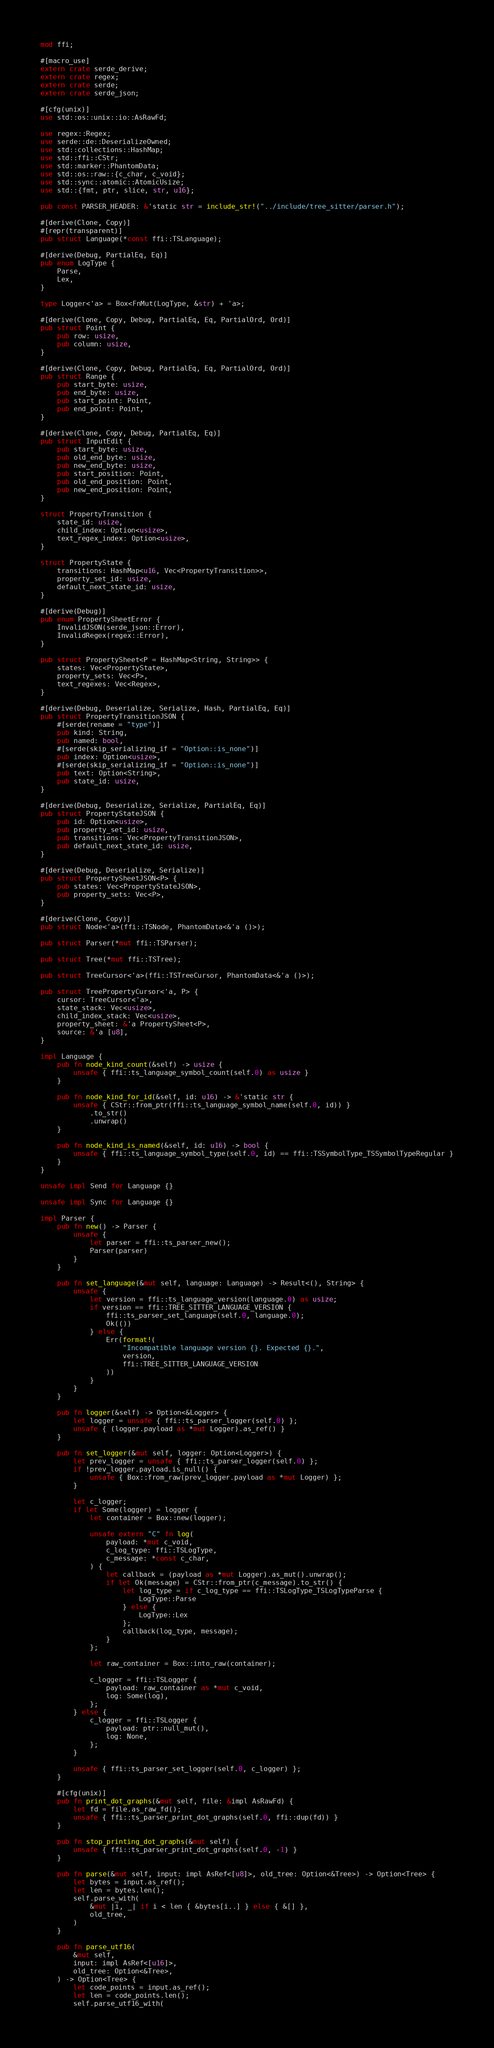<code> <loc_0><loc_0><loc_500><loc_500><_Rust_>mod ffi;

#[macro_use]
extern crate serde_derive;
extern crate regex;
extern crate serde;
extern crate serde_json;

#[cfg(unix)]
use std::os::unix::io::AsRawFd;

use regex::Regex;
use serde::de::DeserializeOwned;
use std::collections::HashMap;
use std::ffi::CStr;
use std::marker::PhantomData;
use std::os::raw::{c_char, c_void};
use std::sync::atomic::AtomicUsize;
use std::{fmt, ptr, slice, str, u16};

pub const PARSER_HEADER: &'static str = include_str!("../include/tree_sitter/parser.h");

#[derive(Clone, Copy)]
#[repr(transparent)]
pub struct Language(*const ffi::TSLanguage);

#[derive(Debug, PartialEq, Eq)]
pub enum LogType {
    Parse,
    Lex,
}

type Logger<'a> = Box<FnMut(LogType, &str) + 'a>;

#[derive(Clone, Copy, Debug, PartialEq, Eq, PartialOrd, Ord)]
pub struct Point {
    pub row: usize,
    pub column: usize,
}

#[derive(Clone, Copy, Debug, PartialEq, Eq, PartialOrd, Ord)]
pub struct Range {
    pub start_byte: usize,
    pub end_byte: usize,
    pub start_point: Point,
    pub end_point: Point,
}

#[derive(Clone, Copy, Debug, PartialEq, Eq)]
pub struct InputEdit {
    pub start_byte: usize,
    pub old_end_byte: usize,
    pub new_end_byte: usize,
    pub start_position: Point,
    pub old_end_position: Point,
    pub new_end_position: Point,
}

struct PropertyTransition {
    state_id: usize,
    child_index: Option<usize>,
    text_regex_index: Option<usize>,
}

struct PropertyState {
    transitions: HashMap<u16, Vec<PropertyTransition>>,
    property_set_id: usize,
    default_next_state_id: usize,
}

#[derive(Debug)]
pub enum PropertySheetError {
    InvalidJSON(serde_json::Error),
    InvalidRegex(regex::Error),
}

pub struct PropertySheet<P = HashMap<String, String>> {
    states: Vec<PropertyState>,
    property_sets: Vec<P>,
    text_regexes: Vec<Regex>,
}

#[derive(Debug, Deserialize, Serialize, Hash, PartialEq, Eq)]
pub struct PropertyTransitionJSON {
    #[serde(rename = "type")]
    pub kind: String,
    pub named: bool,
    #[serde(skip_serializing_if = "Option::is_none")]
    pub index: Option<usize>,
    #[serde(skip_serializing_if = "Option::is_none")]
    pub text: Option<String>,
    pub state_id: usize,
}

#[derive(Debug, Deserialize, Serialize, PartialEq, Eq)]
pub struct PropertyStateJSON {
    pub id: Option<usize>,
    pub property_set_id: usize,
    pub transitions: Vec<PropertyTransitionJSON>,
    pub default_next_state_id: usize,
}

#[derive(Debug, Deserialize, Serialize)]
pub struct PropertySheetJSON<P> {
    pub states: Vec<PropertyStateJSON>,
    pub property_sets: Vec<P>,
}

#[derive(Clone, Copy)]
pub struct Node<'a>(ffi::TSNode, PhantomData<&'a ()>);

pub struct Parser(*mut ffi::TSParser);

pub struct Tree(*mut ffi::TSTree);

pub struct TreeCursor<'a>(ffi::TSTreeCursor, PhantomData<&'a ()>);

pub struct TreePropertyCursor<'a, P> {
    cursor: TreeCursor<'a>,
    state_stack: Vec<usize>,
    child_index_stack: Vec<usize>,
    property_sheet: &'a PropertySheet<P>,
    source: &'a [u8],
}

impl Language {
    pub fn node_kind_count(&self) -> usize {
        unsafe { ffi::ts_language_symbol_count(self.0) as usize }
    }

    pub fn node_kind_for_id(&self, id: u16) -> &'static str {
        unsafe { CStr::from_ptr(ffi::ts_language_symbol_name(self.0, id)) }
            .to_str()
            .unwrap()
    }

    pub fn node_kind_is_named(&self, id: u16) -> bool {
        unsafe { ffi::ts_language_symbol_type(self.0, id) == ffi::TSSymbolType_TSSymbolTypeRegular }
    }
}

unsafe impl Send for Language {}

unsafe impl Sync for Language {}

impl Parser {
    pub fn new() -> Parser {
        unsafe {
            let parser = ffi::ts_parser_new();
            Parser(parser)
        }
    }

    pub fn set_language(&mut self, language: Language) -> Result<(), String> {
        unsafe {
            let version = ffi::ts_language_version(language.0) as usize;
            if version == ffi::TREE_SITTER_LANGUAGE_VERSION {
                ffi::ts_parser_set_language(self.0, language.0);
                Ok(())
            } else {
                Err(format!(
                    "Incompatible language version {}. Expected {}.",
                    version,
                    ffi::TREE_SITTER_LANGUAGE_VERSION
                ))
            }
        }
    }

    pub fn logger(&self) -> Option<&Logger> {
        let logger = unsafe { ffi::ts_parser_logger(self.0) };
        unsafe { (logger.payload as *mut Logger).as_ref() }
    }

    pub fn set_logger(&mut self, logger: Option<Logger>) {
        let prev_logger = unsafe { ffi::ts_parser_logger(self.0) };
        if !prev_logger.payload.is_null() {
            unsafe { Box::from_raw(prev_logger.payload as *mut Logger) };
        }

        let c_logger;
        if let Some(logger) = logger {
            let container = Box::new(logger);

            unsafe extern "C" fn log(
                payload: *mut c_void,
                c_log_type: ffi::TSLogType,
                c_message: *const c_char,
            ) {
                let callback = (payload as *mut Logger).as_mut().unwrap();
                if let Ok(message) = CStr::from_ptr(c_message).to_str() {
                    let log_type = if c_log_type == ffi::TSLogType_TSLogTypeParse {
                        LogType::Parse
                    } else {
                        LogType::Lex
                    };
                    callback(log_type, message);
                }
            };

            let raw_container = Box::into_raw(container);

            c_logger = ffi::TSLogger {
                payload: raw_container as *mut c_void,
                log: Some(log),
            };
        } else {
            c_logger = ffi::TSLogger {
                payload: ptr::null_mut(),
                log: None,
            };
        }

        unsafe { ffi::ts_parser_set_logger(self.0, c_logger) };
    }

    #[cfg(unix)]
    pub fn print_dot_graphs(&mut self, file: &impl AsRawFd) {
        let fd = file.as_raw_fd();
        unsafe { ffi::ts_parser_print_dot_graphs(self.0, ffi::dup(fd)) }
    }

    pub fn stop_printing_dot_graphs(&mut self) {
        unsafe { ffi::ts_parser_print_dot_graphs(self.0, -1) }
    }

    pub fn parse(&mut self, input: impl AsRef<[u8]>, old_tree: Option<&Tree>) -> Option<Tree> {
        let bytes = input.as_ref();
        let len = bytes.len();
        self.parse_with(
            &mut |i, _| if i < len { &bytes[i..] } else { &[] },
            old_tree,
        )
    }

    pub fn parse_utf16(
        &mut self,
        input: impl AsRef<[u16]>,
        old_tree: Option<&Tree>,
    ) -> Option<Tree> {
        let code_points = input.as_ref();
        let len = code_points.len();
        self.parse_utf16_with(</code> 